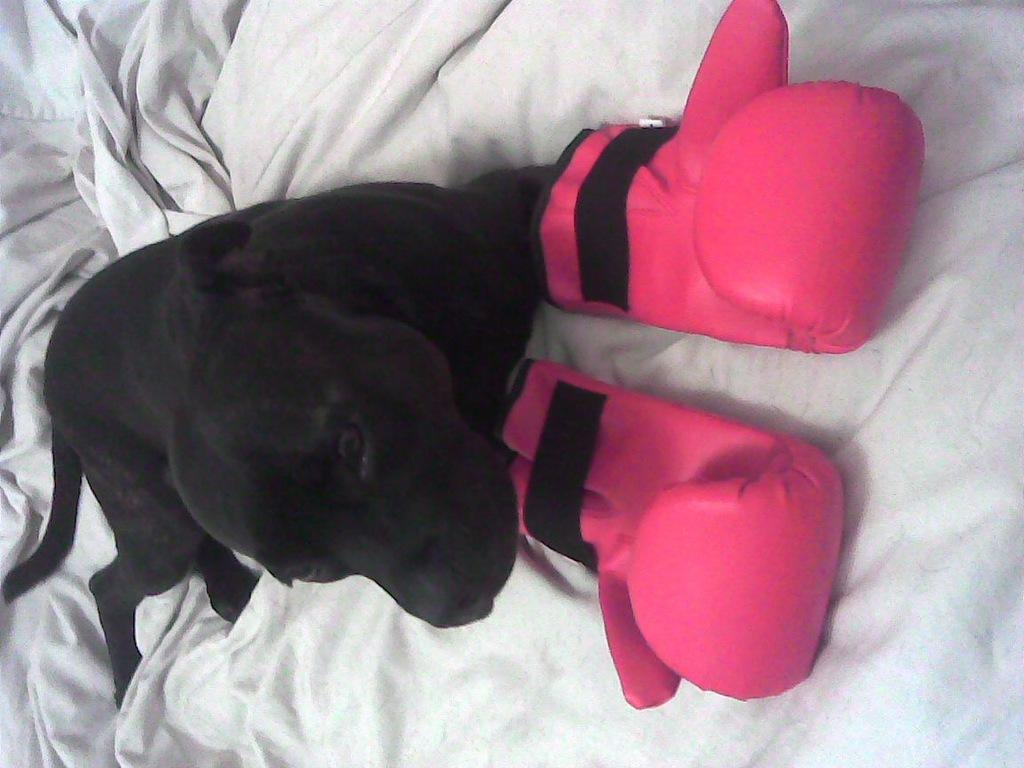What piece of furniture is present in the image? There is a bed in the image. How is the bed decorated or covered? The bed is covered with a blanket. What type of animal is on the bed? There is a black-colored dog on the bed. What is unusual about the dog in the image? The dog is wearing gloves. What month is depicted in the image? There is no month depicted in the image; it features a bed with a dog wearing gloves. Can you see any sidewalks in the image? There are no sidewalks present in the image. 